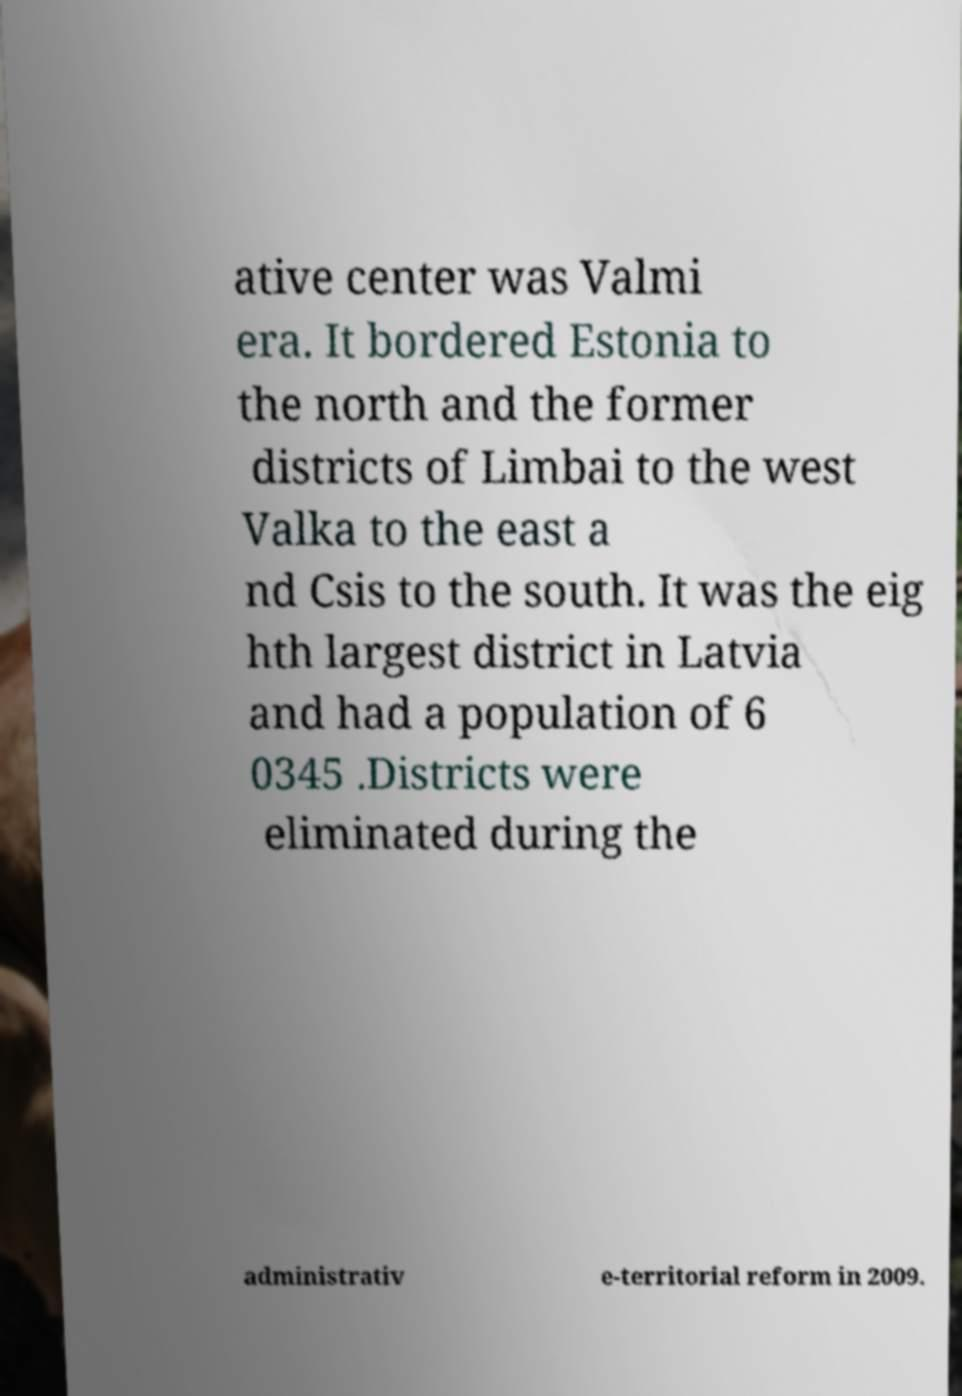Could you assist in decoding the text presented in this image and type it out clearly? ative center was Valmi era. It bordered Estonia to the north and the former districts of Limbai to the west Valka to the east a nd Csis to the south. It was the eig hth largest district in Latvia and had a population of 6 0345 .Districts were eliminated during the administrativ e-territorial reform in 2009. 